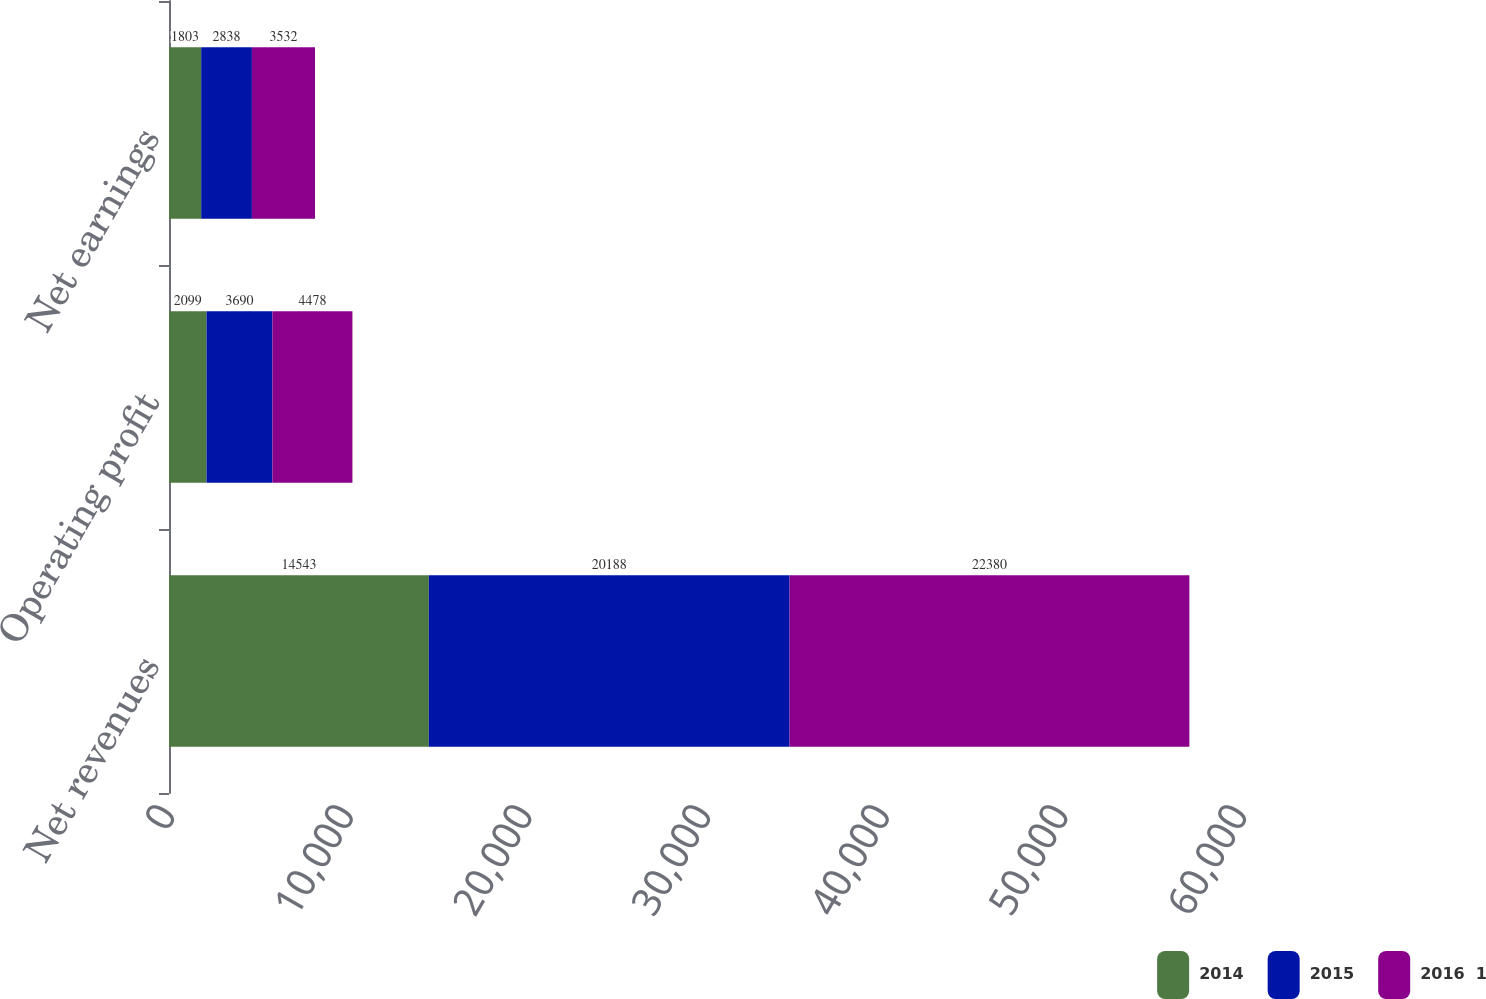Convert chart to OTSL. <chart><loc_0><loc_0><loc_500><loc_500><stacked_bar_chart><ecel><fcel>Net revenues<fcel>Operating profit<fcel>Net earnings<nl><fcel>2014<fcel>14543<fcel>2099<fcel>1803<nl><fcel>2015<fcel>20188<fcel>3690<fcel>2838<nl><fcel>2016  1<fcel>22380<fcel>4478<fcel>3532<nl></chart> 